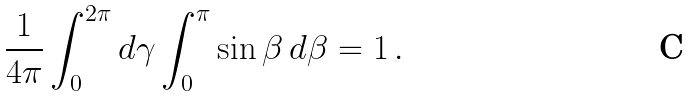<formula> <loc_0><loc_0><loc_500><loc_500>\frac { 1 } { 4 \pi } \int _ { 0 } ^ { 2 \pi } d \gamma \int _ { 0 } ^ { \pi } \sin \beta \, d \beta = 1 \, .</formula> 